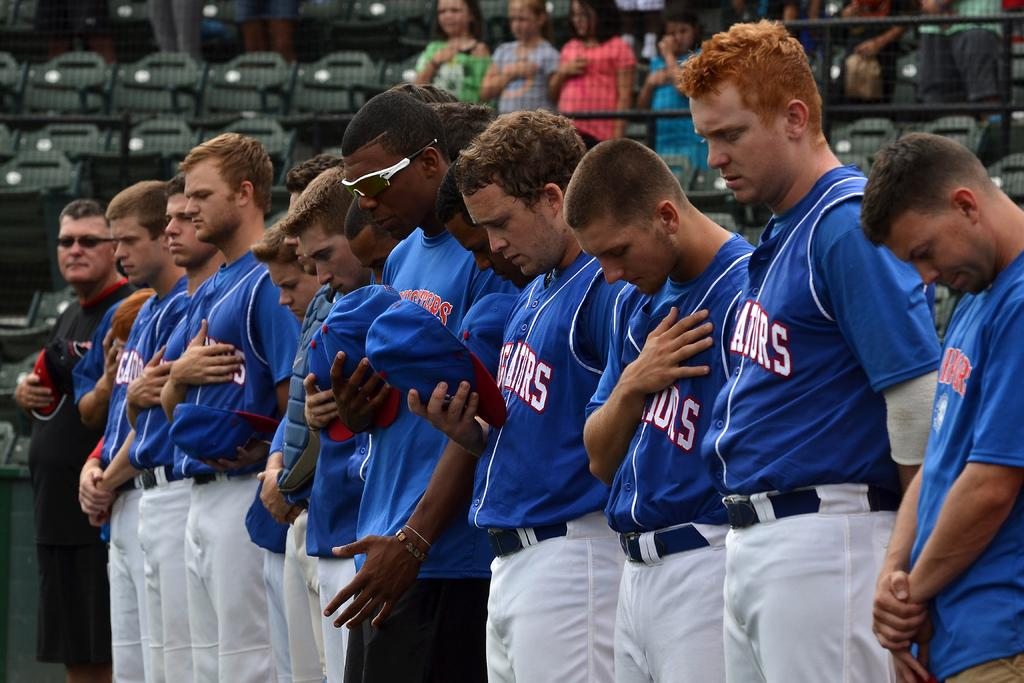What is the main subject of the image? The main subject of the image is a group of men. Where are the men located in the image? The men are standing on the ground. What can be seen in the background of the image? There is fencing and persons in the background of the image. Are there any objects visible in the background? Yes, there are chairs in the background of the image. What type of activity are the men participating in, as seen in the image? The image does not show the men participating in any specific activity. Can you tell me how many times the men have bitten their nails in the image? There is no indication of the men biting their nails in the image. 